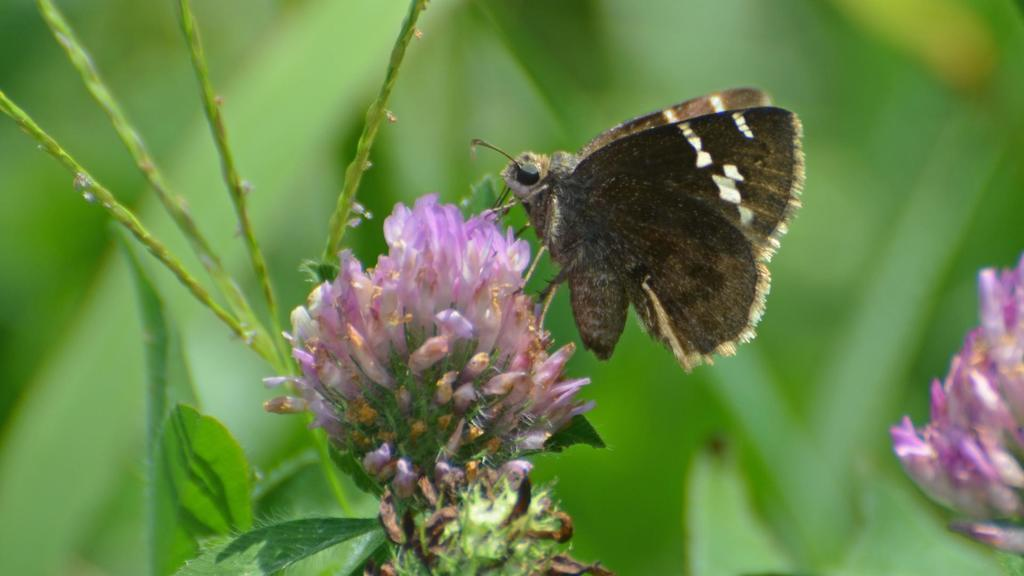What is the main subject of the image? There is a butterfly in the image. Where is the butterfly located? The butterfly is on a flower. What color is the flower? The flower is pink. How would you describe the background of the image? The background of the image is blurred, and the background color is green. What type of cushion is being used to support the butterfly in the image? There is no cushion present in the image; the butterfly is on a flower. 